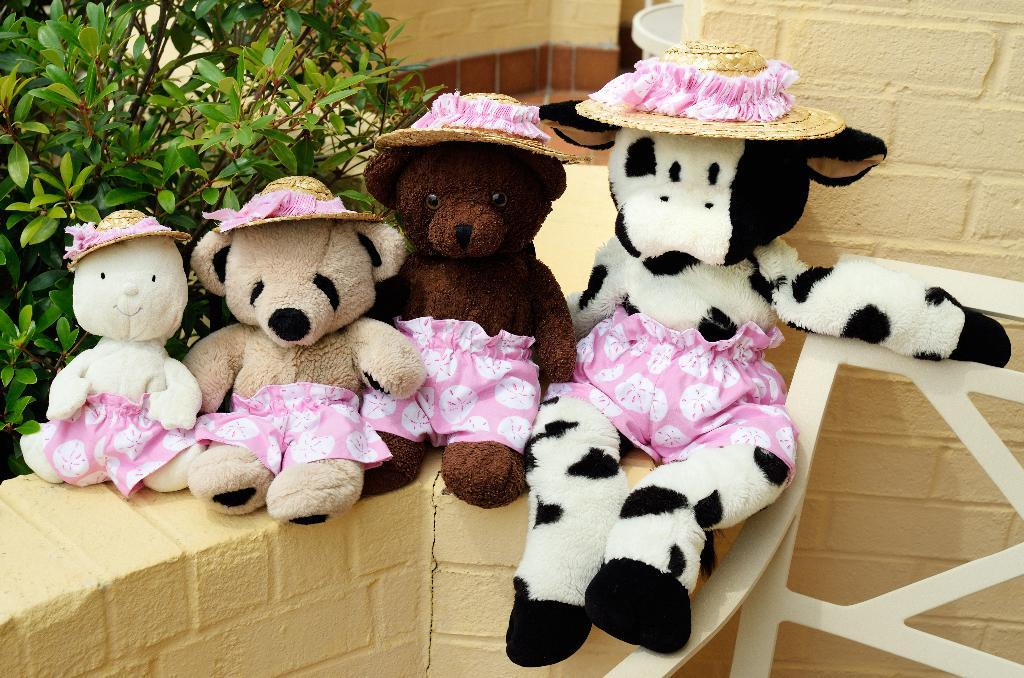What type of stuffed animals are in the image? There are teddy bears in the image. What are the teddy bears wearing? The teddy bears are wearing hats. Where are the teddy bears located in the image? The teddy bears are on the wall. What is visible behind the teddy bears? There is a wall visible behind the teddy bears. What type of sign is hanging from the throat of the teddy bear in the image? There is no sign present in the image, and the teddy bears do not have throats. 